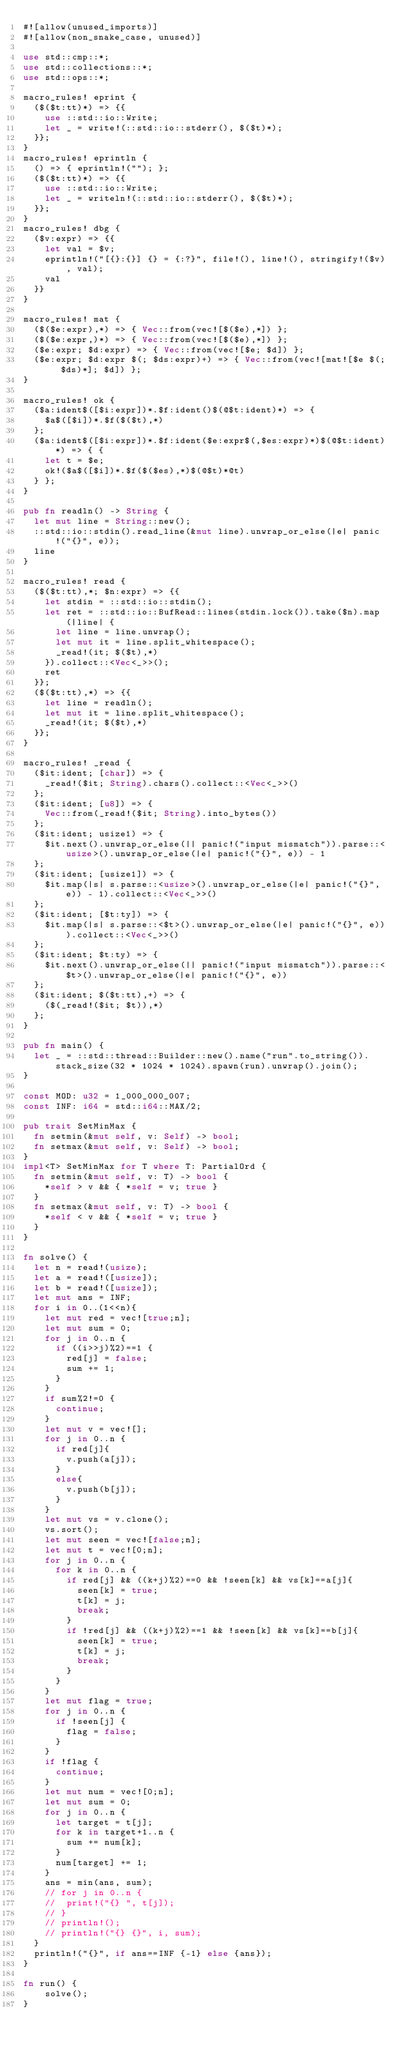Convert code to text. <code><loc_0><loc_0><loc_500><loc_500><_Rust_>#![allow(unused_imports)]
#![allow(non_snake_case, unused)]

use std::cmp::*;
use std::collections::*;
use std::ops::*;

macro_rules! eprint {
	($($t:tt)*) => {{
		use ::std::io::Write;
		let _ = write!(::std::io::stderr(), $($t)*);
	}};
}
macro_rules! eprintln {
	() => { eprintln!(""); };
	($($t:tt)*) => {{
		use ::std::io::Write;
		let _ = writeln!(::std::io::stderr(), $($t)*);
	}};
}
macro_rules! dbg {
	($v:expr) => {{
		let val = $v;
		eprintln!("[{}:{}] {} = {:?}", file!(), line!(), stringify!($v), val);
		val
	}}
}

macro_rules! mat {
	($($e:expr),*) => { Vec::from(vec![$($e),*]) };
	($($e:expr,)*) => { Vec::from(vec![$($e),*]) };
	($e:expr; $d:expr) => { Vec::from(vec![$e; $d]) };
	($e:expr; $d:expr $(; $ds:expr)+) => { Vec::from(vec![mat![$e $(; $ds)*]; $d]) };
}

macro_rules! ok {
	($a:ident$([$i:expr])*.$f:ident()$(@$t:ident)*) => {
		$a$([$i])*.$f($($t),*)
	};
	($a:ident$([$i:expr])*.$f:ident($e:expr$(,$es:expr)*)$(@$t:ident)*) => { {
		let t = $e;
		ok!($a$([$i])*.$f($($es),*)$(@$t)*@t)
	} };
}

pub fn readln() -> String {
	let mut line = String::new();
	::std::io::stdin().read_line(&mut line).unwrap_or_else(|e| panic!("{}", e));
	line
}

macro_rules! read {
	($($t:tt),*; $n:expr) => {{
		let stdin = ::std::io::stdin();
		let ret = ::std::io::BufRead::lines(stdin.lock()).take($n).map(|line| {
			let line = line.unwrap();
			let mut it = line.split_whitespace();
			_read!(it; $($t),*)
		}).collect::<Vec<_>>();
		ret
	}};
	($($t:tt),*) => {{
		let line = readln();
		let mut it = line.split_whitespace();
		_read!(it; $($t),*)
	}};
}

macro_rules! _read {
	($it:ident; [char]) => {
		_read!($it; String).chars().collect::<Vec<_>>()
	};
	($it:ident; [u8]) => {
		Vec::from(_read!($it; String).into_bytes())
	};
	($it:ident; usize1) => {
		$it.next().unwrap_or_else(|| panic!("input mismatch")).parse::<usize>().unwrap_or_else(|e| panic!("{}", e)) - 1
	};
	($it:ident; [usize1]) => {
		$it.map(|s| s.parse::<usize>().unwrap_or_else(|e| panic!("{}", e)) - 1).collect::<Vec<_>>()
	};
	($it:ident; [$t:ty]) => {
		$it.map(|s| s.parse::<$t>().unwrap_or_else(|e| panic!("{}", e))).collect::<Vec<_>>()
	};
	($it:ident; $t:ty) => {
		$it.next().unwrap_or_else(|| panic!("input mismatch")).parse::<$t>().unwrap_or_else(|e| panic!("{}", e))
	};
	($it:ident; $($t:tt),+) => {
		($(_read!($it; $t)),*)
	};
}

pub fn main() {
	let _ = ::std::thread::Builder::new().name("run".to_string()).stack_size(32 * 1024 * 1024).spawn(run).unwrap().join();
}

const MOD: u32 = 1_000_000_007;
const INF: i64 = std::i64::MAX/2;

pub trait SetMinMax {
	fn setmin(&mut self, v: Self) -> bool;
	fn setmax(&mut self, v: Self) -> bool;
}
impl<T> SetMinMax for T where T: PartialOrd {
	fn setmin(&mut self, v: T) -> bool {
		*self > v && { *self = v; true }
	}
	fn setmax(&mut self, v: T) -> bool {
		*self < v && { *self = v; true }
	}
}

fn solve() {
	let n = read!(usize);
	let a = read!([usize]);
	let b = read!([usize]);
	let mut ans = INF;
	for i in 0..(1<<n){
		let mut red = vec![true;n];
		let mut sum = 0;
		for j in 0..n {
			if ((i>>j)%2)==1 {
				red[j] = false;
				sum += 1;
			}
		}
		if sum%2!=0 {
			continue;
		}
		let mut v = vec![];
		for j in 0..n {
			if red[j]{
				v.push(a[j]);
			}
			else{
				v.push(b[j]);
			}
		}
		let mut vs = v.clone();
		vs.sort();
		let mut seen = vec![false;n];
		let mut t = vec![0;n];
		for j in 0..n {
			for k in 0..n {
				if red[j] && ((k+j)%2)==0 && !seen[k] && vs[k]==a[j]{
					seen[k] = true;
					t[k] = j;
					break;
				}
				if !red[j] && ((k+j)%2)==1 && !seen[k] && vs[k]==b[j]{
					seen[k] = true;
					t[k] = j;
					break;
				}
			}
		}
		let mut flag = true;
		for j in 0..n {
			if !seen[j] {
				flag = false;
			}
		}
		if !flag {
			continue;
		}
		let mut num = vec![0;n];
		let mut sum = 0;
		for j in 0..n {
			let target = t[j];
			for k in target+1..n {
				sum += num[k];
			}
			num[target] += 1;
		}
		ans = min(ans, sum);
		// for j in 0..n {
		// 	print!("{} ", t[j]);
		// }
		// println!();
		// println!("{} {}", i, sum);
	}
	println!("{}", if ans==INF {-1} else {ans});
}

fn run() {
    solve();
}
</code> 